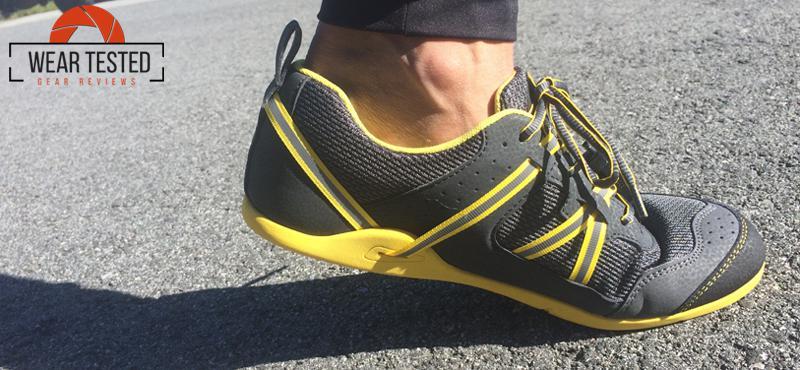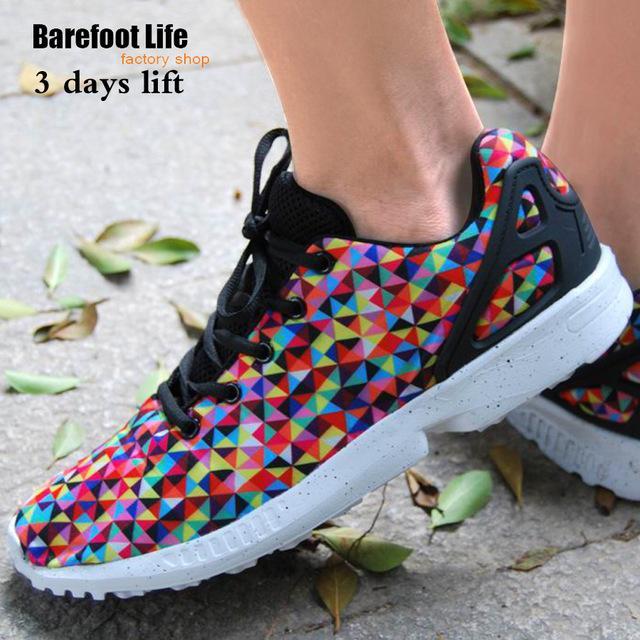The first image is the image on the left, the second image is the image on the right. For the images shown, is this caption "One image shows a pair of feet in sneakers, and the other shows a pair of unworn shoes, one turned so its sole faces the camera." true? Answer yes or no. No. The first image is the image on the left, the second image is the image on the right. For the images displayed, is the sentence "The left hand image shows both the top and the bottom of the pair of shoes that are not on a person, while the right hand image shows shoes being worn by a human." factually correct? Answer yes or no. No. 